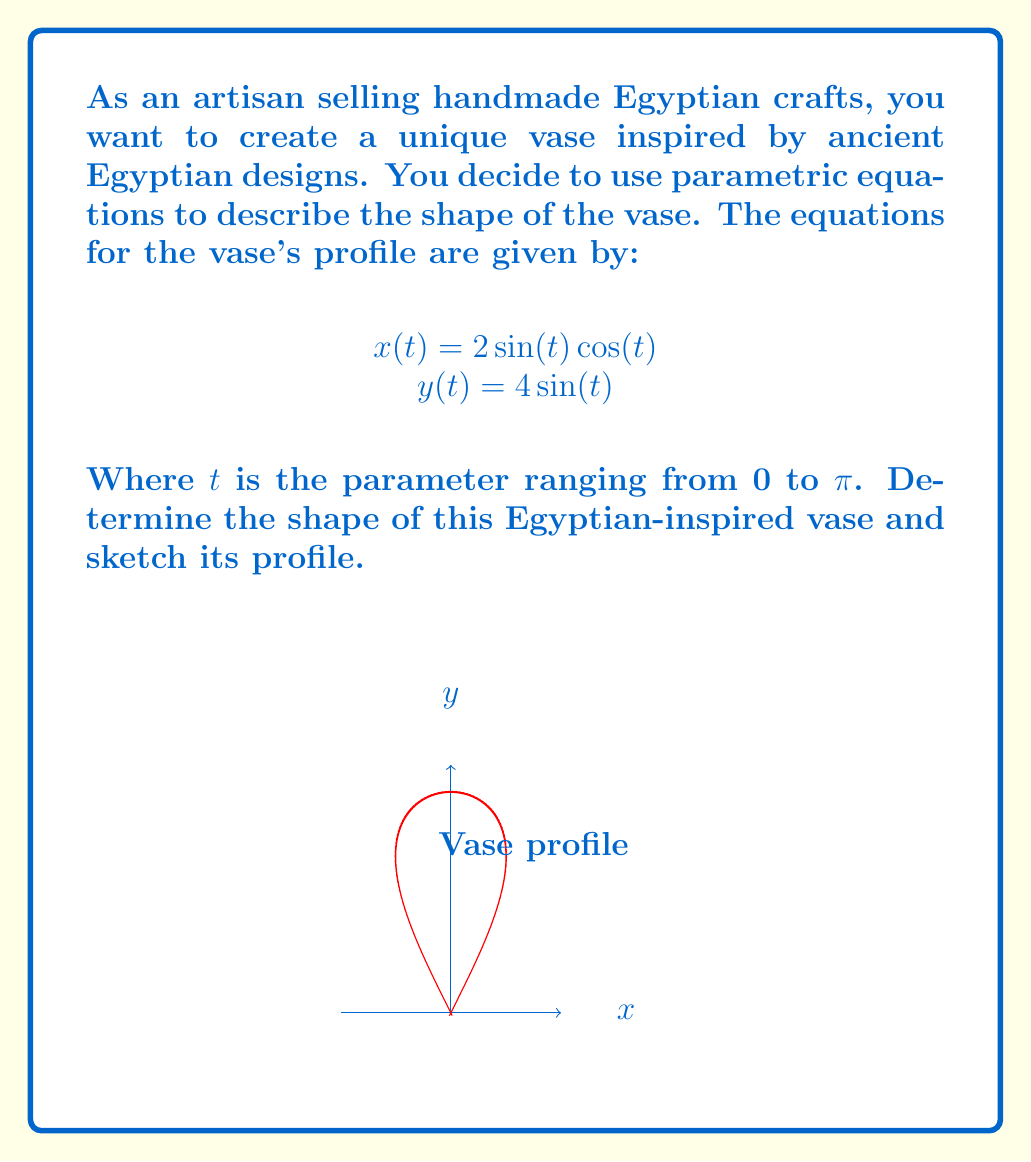Solve this math problem. To determine the shape of the vase, let's analyze the parametric equations:

1) First, we recognize that $x(t) = 2 \sin(t) \cos(t)$ can be simplified using the double angle formula:
   $$x(t) = \sin(2t)$$

2) Now we have:
   $$x(t) = \sin(2t)$$
   $$y(t) = 4 \sin(t)$$

3) To identify the shape, let's eliminate the parameter $t$:
   
   From $y(t) = 4 \sin(t)$, we get: $\sin(t) = \frac{y}{4}$
   
   Squaring both sides of $x(t) = \sin(2t)$:
   $$x^2 = \sin^2(2t) = 4\sin^2(t)\cos^2(t)$$

4) Using the identity $\cos^2(t) = 1 - \sin^2(t)$:
   $$x^2 = 4\sin^2(t)(1-\sin^2(t)) = 4(\frac{y}{4})^2(1-(\frac{y}{4})^2)$$

5) Simplifying:
   $$x^2 = \frac{y^2}{4}(1-\frac{y^2}{16}) = \frac{y^2}{4} - \frac{y^4}{64}$$

6) Multiplying both sides by 64:
   $$64x^2 = 16y^2 - y^4$$

7) Rearranging:
   $$y^4 - 16y^2 + 64x^2 = 0$$

This is the equation of a lemniscate, a figure-eight shaped curve. The vase profile is the upper half of this lemniscate, as $t$ ranges from 0 to $\pi$.

The resulting shape resembles a slender vase with a narrow neck and a wider body, typical of many ancient Egyptian vase designs.
Answer: The shape is the upper half of a lemniscate, described by $y^4 - 16y^2 + 64x^2 = 0$ for $y \geq 0$. 